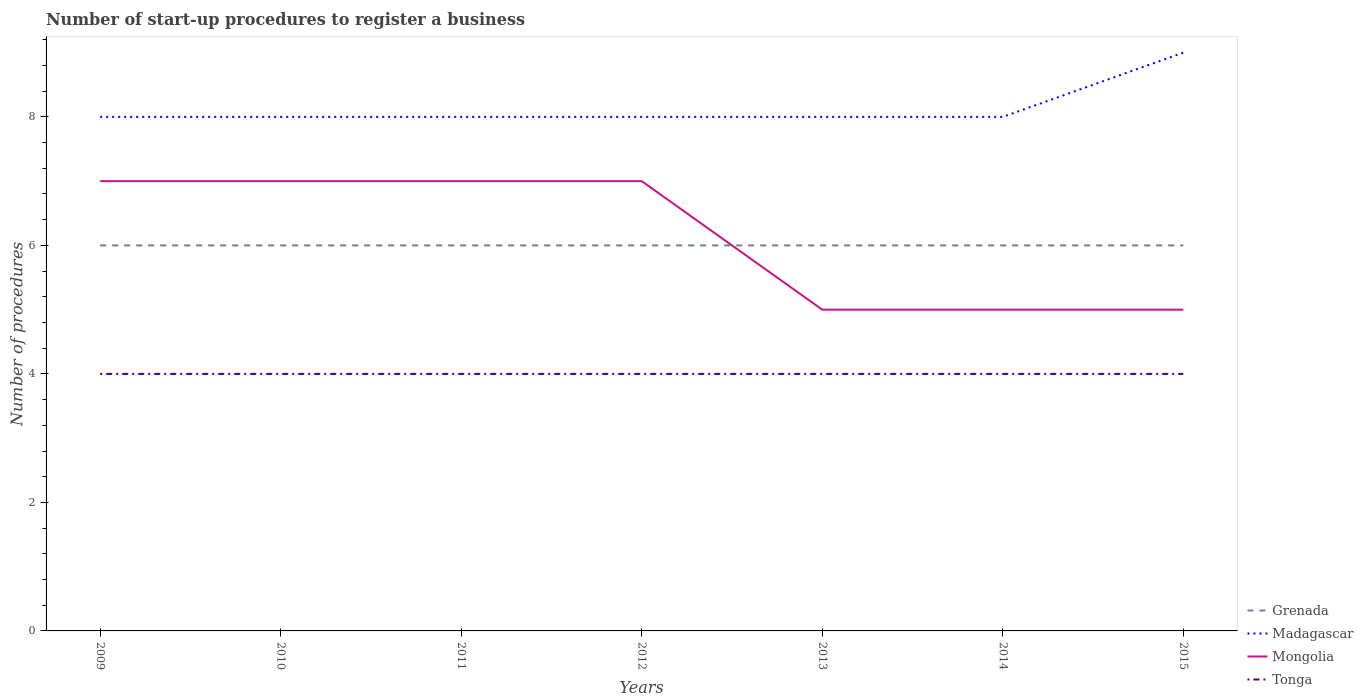Does the line corresponding to Tonga intersect with the line corresponding to Grenada?
Make the answer very short. No. Is the number of lines equal to the number of legend labels?
Offer a terse response. Yes. Across all years, what is the maximum number of procedures required to register a business in Madagascar?
Offer a terse response. 8. In which year was the number of procedures required to register a business in Tonga maximum?
Give a very brief answer. 2009. What is the difference between the highest and the second highest number of procedures required to register a business in Grenada?
Ensure brevity in your answer.  0. What is the difference between the highest and the lowest number of procedures required to register a business in Mongolia?
Your answer should be compact. 4. How many lines are there?
Ensure brevity in your answer.  4. Does the graph contain grids?
Provide a short and direct response. No. Where does the legend appear in the graph?
Offer a very short reply. Bottom right. How many legend labels are there?
Your answer should be compact. 4. How are the legend labels stacked?
Your answer should be compact. Vertical. What is the title of the graph?
Your answer should be compact. Number of start-up procedures to register a business. What is the label or title of the X-axis?
Offer a terse response. Years. What is the label or title of the Y-axis?
Your answer should be compact. Number of procedures. What is the Number of procedures of Grenada in 2009?
Provide a succinct answer. 6. What is the Number of procedures of Mongolia in 2009?
Your answer should be very brief. 7. What is the Number of procedures in Tonga in 2009?
Offer a very short reply. 4. What is the Number of procedures in Grenada in 2010?
Make the answer very short. 6. What is the Number of procedures of Madagascar in 2010?
Offer a terse response. 8. What is the Number of procedures of Mongolia in 2010?
Make the answer very short. 7. What is the Number of procedures in Tonga in 2010?
Your response must be concise. 4. What is the Number of procedures of Grenada in 2011?
Make the answer very short. 6. What is the Number of procedures of Mongolia in 2011?
Offer a very short reply. 7. What is the Number of procedures of Madagascar in 2012?
Make the answer very short. 8. What is the Number of procedures in Tonga in 2012?
Make the answer very short. 4. What is the Number of procedures of Madagascar in 2013?
Your answer should be very brief. 8. What is the Number of procedures of Mongolia in 2013?
Offer a very short reply. 5. What is the Number of procedures of Tonga in 2013?
Give a very brief answer. 4. What is the Number of procedures in Madagascar in 2014?
Provide a succinct answer. 8. What is the Number of procedures of Tonga in 2014?
Make the answer very short. 4. What is the Number of procedures in Madagascar in 2015?
Keep it short and to the point. 9. What is the Number of procedures in Mongolia in 2015?
Provide a succinct answer. 5. Across all years, what is the maximum Number of procedures in Grenada?
Give a very brief answer. 6. Across all years, what is the maximum Number of procedures of Tonga?
Keep it short and to the point. 4. Across all years, what is the minimum Number of procedures in Grenada?
Provide a succinct answer. 6. Across all years, what is the minimum Number of procedures of Mongolia?
Make the answer very short. 5. Across all years, what is the minimum Number of procedures of Tonga?
Provide a short and direct response. 4. What is the total Number of procedures of Grenada in the graph?
Your answer should be compact. 42. What is the total Number of procedures of Tonga in the graph?
Offer a very short reply. 28. What is the difference between the Number of procedures of Mongolia in 2009 and that in 2010?
Make the answer very short. 0. What is the difference between the Number of procedures in Tonga in 2009 and that in 2010?
Your answer should be compact. 0. What is the difference between the Number of procedures of Madagascar in 2009 and that in 2011?
Offer a terse response. 0. What is the difference between the Number of procedures in Mongolia in 2009 and that in 2011?
Offer a terse response. 0. What is the difference between the Number of procedures in Tonga in 2009 and that in 2011?
Your answer should be very brief. 0. What is the difference between the Number of procedures in Madagascar in 2009 and that in 2012?
Offer a very short reply. 0. What is the difference between the Number of procedures in Tonga in 2009 and that in 2012?
Provide a succinct answer. 0. What is the difference between the Number of procedures of Grenada in 2009 and that in 2013?
Keep it short and to the point. 0. What is the difference between the Number of procedures of Madagascar in 2009 and that in 2013?
Offer a terse response. 0. What is the difference between the Number of procedures of Grenada in 2009 and that in 2014?
Provide a succinct answer. 0. What is the difference between the Number of procedures in Madagascar in 2009 and that in 2014?
Your answer should be compact. 0. What is the difference between the Number of procedures of Madagascar in 2009 and that in 2015?
Give a very brief answer. -1. What is the difference between the Number of procedures in Mongolia in 2009 and that in 2015?
Your answer should be very brief. 2. What is the difference between the Number of procedures in Tonga in 2010 and that in 2011?
Offer a terse response. 0. What is the difference between the Number of procedures in Grenada in 2010 and that in 2012?
Keep it short and to the point. 0. What is the difference between the Number of procedures in Madagascar in 2010 and that in 2013?
Offer a terse response. 0. What is the difference between the Number of procedures in Mongolia in 2010 and that in 2013?
Provide a succinct answer. 2. What is the difference between the Number of procedures in Tonga in 2010 and that in 2013?
Keep it short and to the point. 0. What is the difference between the Number of procedures of Grenada in 2010 and that in 2014?
Provide a short and direct response. 0. What is the difference between the Number of procedures of Madagascar in 2010 and that in 2014?
Offer a terse response. 0. What is the difference between the Number of procedures in Mongolia in 2010 and that in 2014?
Give a very brief answer. 2. What is the difference between the Number of procedures of Tonga in 2010 and that in 2014?
Offer a terse response. 0. What is the difference between the Number of procedures in Grenada in 2010 and that in 2015?
Make the answer very short. 0. What is the difference between the Number of procedures in Mongolia in 2010 and that in 2015?
Make the answer very short. 2. What is the difference between the Number of procedures of Tonga in 2010 and that in 2015?
Provide a short and direct response. 0. What is the difference between the Number of procedures in Grenada in 2011 and that in 2012?
Keep it short and to the point. 0. What is the difference between the Number of procedures of Mongolia in 2011 and that in 2012?
Keep it short and to the point. 0. What is the difference between the Number of procedures in Tonga in 2011 and that in 2012?
Provide a succinct answer. 0. What is the difference between the Number of procedures of Grenada in 2011 and that in 2013?
Make the answer very short. 0. What is the difference between the Number of procedures of Madagascar in 2011 and that in 2013?
Offer a terse response. 0. What is the difference between the Number of procedures of Tonga in 2011 and that in 2013?
Keep it short and to the point. 0. What is the difference between the Number of procedures in Mongolia in 2011 and that in 2014?
Make the answer very short. 2. What is the difference between the Number of procedures in Madagascar in 2011 and that in 2015?
Your answer should be compact. -1. What is the difference between the Number of procedures of Mongolia in 2011 and that in 2015?
Make the answer very short. 2. What is the difference between the Number of procedures in Grenada in 2012 and that in 2013?
Your answer should be compact. 0. What is the difference between the Number of procedures in Mongolia in 2012 and that in 2013?
Offer a very short reply. 2. What is the difference between the Number of procedures in Madagascar in 2012 and that in 2014?
Offer a terse response. 0. What is the difference between the Number of procedures of Madagascar in 2012 and that in 2015?
Ensure brevity in your answer.  -1. What is the difference between the Number of procedures in Mongolia in 2012 and that in 2015?
Offer a very short reply. 2. What is the difference between the Number of procedures in Madagascar in 2013 and that in 2014?
Give a very brief answer. 0. What is the difference between the Number of procedures of Mongolia in 2013 and that in 2014?
Provide a short and direct response. 0. What is the difference between the Number of procedures of Grenada in 2013 and that in 2015?
Your answer should be compact. 0. What is the difference between the Number of procedures in Madagascar in 2014 and that in 2015?
Provide a succinct answer. -1. What is the difference between the Number of procedures of Grenada in 2009 and the Number of procedures of Madagascar in 2010?
Offer a very short reply. -2. What is the difference between the Number of procedures in Grenada in 2009 and the Number of procedures in Mongolia in 2010?
Your answer should be compact. -1. What is the difference between the Number of procedures of Grenada in 2009 and the Number of procedures of Tonga in 2010?
Ensure brevity in your answer.  2. What is the difference between the Number of procedures in Mongolia in 2009 and the Number of procedures in Tonga in 2010?
Your answer should be compact. 3. What is the difference between the Number of procedures of Grenada in 2009 and the Number of procedures of Madagascar in 2011?
Provide a short and direct response. -2. What is the difference between the Number of procedures of Grenada in 2009 and the Number of procedures of Mongolia in 2011?
Make the answer very short. -1. What is the difference between the Number of procedures in Grenada in 2009 and the Number of procedures in Tonga in 2011?
Provide a short and direct response. 2. What is the difference between the Number of procedures of Mongolia in 2009 and the Number of procedures of Tonga in 2011?
Your answer should be very brief. 3. What is the difference between the Number of procedures of Grenada in 2009 and the Number of procedures of Madagascar in 2012?
Provide a short and direct response. -2. What is the difference between the Number of procedures in Madagascar in 2009 and the Number of procedures in Mongolia in 2012?
Provide a short and direct response. 1. What is the difference between the Number of procedures in Madagascar in 2009 and the Number of procedures in Tonga in 2012?
Keep it short and to the point. 4. What is the difference between the Number of procedures of Mongolia in 2009 and the Number of procedures of Tonga in 2012?
Give a very brief answer. 3. What is the difference between the Number of procedures of Mongolia in 2009 and the Number of procedures of Tonga in 2013?
Your answer should be very brief. 3. What is the difference between the Number of procedures in Grenada in 2009 and the Number of procedures in Madagascar in 2014?
Your answer should be compact. -2. What is the difference between the Number of procedures in Grenada in 2009 and the Number of procedures in Mongolia in 2014?
Make the answer very short. 1. What is the difference between the Number of procedures of Grenada in 2009 and the Number of procedures of Tonga in 2014?
Provide a short and direct response. 2. What is the difference between the Number of procedures in Madagascar in 2009 and the Number of procedures in Mongolia in 2014?
Offer a very short reply. 3. What is the difference between the Number of procedures in Mongolia in 2009 and the Number of procedures in Tonga in 2014?
Provide a succinct answer. 3. What is the difference between the Number of procedures in Grenada in 2009 and the Number of procedures in Mongolia in 2015?
Keep it short and to the point. 1. What is the difference between the Number of procedures of Grenada in 2009 and the Number of procedures of Tonga in 2015?
Offer a very short reply. 2. What is the difference between the Number of procedures of Grenada in 2010 and the Number of procedures of Madagascar in 2011?
Make the answer very short. -2. What is the difference between the Number of procedures of Madagascar in 2010 and the Number of procedures of Tonga in 2011?
Your answer should be compact. 4. What is the difference between the Number of procedures of Grenada in 2010 and the Number of procedures of Mongolia in 2012?
Provide a short and direct response. -1. What is the difference between the Number of procedures of Grenada in 2010 and the Number of procedures of Tonga in 2012?
Ensure brevity in your answer.  2. What is the difference between the Number of procedures of Madagascar in 2010 and the Number of procedures of Tonga in 2012?
Your answer should be compact. 4. What is the difference between the Number of procedures in Grenada in 2010 and the Number of procedures in Tonga in 2013?
Offer a very short reply. 2. What is the difference between the Number of procedures in Mongolia in 2010 and the Number of procedures in Tonga in 2013?
Give a very brief answer. 3. What is the difference between the Number of procedures in Grenada in 2010 and the Number of procedures in Madagascar in 2014?
Give a very brief answer. -2. What is the difference between the Number of procedures of Madagascar in 2010 and the Number of procedures of Mongolia in 2014?
Provide a succinct answer. 3. What is the difference between the Number of procedures of Madagascar in 2010 and the Number of procedures of Tonga in 2014?
Offer a very short reply. 4. What is the difference between the Number of procedures of Mongolia in 2010 and the Number of procedures of Tonga in 2014?
Your answer should be compact. 3. What is the difference between the Number of procedures in Grenada in 2010 and the Number of procedures in Madagascar in 2015?
Offer a very short reply. -3. What is the difference between the Number of procedures in Grenada in 2010 and the Number of procedures in Mongolia in 2015?
Provide a succinct answer. 1. What is the difference between the Number of procedures in Madagascar in 2010 and the Number of procedures in Tonga in 2015?
Offer a terse response. 4. What is the difference between the Number of procedures in Mongolia in 2010 and the Number of procedures in Tonga in 2015?
Your answer should be compact. 3. What is the difference between the Number of procedures in Grenada in 2011 and the Number of procedures in Madagascar in 2012?
Offer a terse response. -2. What is the difference between the Number of procedures in Grenada in 2011 and the Number of procedures in Mongolia in 2012?
Give a very brief answer. -1. What is the difference between the Number of procedures of Madagascar in 2011 and the Number of procedures of Tonga in 2012?
Your answer should be compact. 4. What is the difference between the Number of procedures of Mongolia in 2011 and the Number of procedures of Tonga in 2012?
Offer a very short reply. 3. What is the difference between the Number of procedures of Grenada in 2011 and the Number of procedures of Mongolia in 2013?
Your response must be concise. 1. What is the difference between the Number of procedures in Grenada in 2011 and the Number of procedures in Tonga in 2013?
Offer a terse response. 2. What is the difference between the Number of procedures of Mongolia in 2011 and the Number of procedures of Tonga in 2013?
Provide a succinct answer. 3. What is the difference between the Number of procedures in Grenada in 2011 and the Number of procedures in Madagascar in 2014?
Give a very brief answer. -2. What is the difference between the Number of procedures of Grenada in 2011 and the Number of procedures of Mongolia in 2014?
Provide a short and direct response. 1. What is the difference between the Number of procedures of Mongolia in 2011 and the Number of procedures of Tonga in 2014?
Ensure brevity in your answer.  3. What is the difference between the Number of procedures of Grenada in 2011 and the Number of procedures of Madagascar in 2015?
Offer a very short reply. -3. What is the difference between the Number of procedures of Madagascar in 2011 and the Number of procedures of Tonga in 2015?
Provide a succinct answer. 4. What is the difference between the Number of procedures in Grenada in 2012 and the Number of procedures in Mongolia in 2013?
Your answer should be very brief. 1. What is the difference between the Number of procedures of Grenada in 2012 and the Number of procedures of Tonga in 2013?
Keep it short and to the point. 2. What is the difference between the Number of procedures in Madagascar in 2012 and the Number of procedures in Tonga in 2013?
Provide a short and direct response. 4. What is the difference between the Number of procedures of Grenada in 2012 and the Number of procedures of Madagascar in 2014?
Provide a short and direct response. -2. What is the difference between the Number of procedures in Grenada in 2012 and the Number of procedures in Mongolia in 2014?
Give a very brief answer. 1. What is the difference between the Number of procedures of Madagascar in 2012 and the Number of procedures of Mongolia in 2014?
Keep it short and to the point. 3. What is the difference between the Number of procedures of Madagascar in 2012 and the Number of procedures of Tonga in 2014?
Your response must be concise. 4. What is the difference between the Number of procedures in Grenada in 2012 and the Number of procedures in Madagascar in 2015?
Offer a terse response. -3. What is the difference between the Number of procedures of Grenada in 2012 and the Number of procedures of Mongolia in 2015?
Ensure brevity in your answer.  1. What is the difference between the Number of procedures of Grenada in 2012 and the Number of procedures of Tonga in 2015?
Keep it short and to the point. 2. What is the difference between the Number of procedures of Madagascar in 2012 and the Number of procedures of Mongolia in 2015?
Offer a terse response. 3. What is the difference between the Number of procedures in Madagascar in 2012 and the Number of procedures in Tonga in 2015?
Provide a succinct answer. 4. What is the difference between the Number of procedures of Mongolia in 2012 and the Number of procedures of Tonga in 2015?
Offer a terse response. 3. What is the difference between the Number of procedures in Madagascar in 2013 and the Number of procedures in Tonga in 2014?
Offer a very short reply. 4. What is the difference between the Number of procedures of Mongolia in 2013 and the Number of procedures of Tonga in 2014?
Provide a succinct answer. 1. What is the difference between the Number of procedures of Grenada in 2013 and the Number of procedures of Madagascar in 2015?
Your answer should be compact. -3. What is the difference between the Number of procedures in Grenada in 2013 and the Number of procedures in Mongolia in 2015?
Provide a short and direct response. 1. What is the difference between the Number of procedures in Grenada in 2013 and the Number of procedures in Tonga in 2015?
Give a very brief answer. 2. What is the difference between the Number of procedures in Madagascar in 2013 and the Number of procedures in Mongolia in 2015?
Provide a succinct answer. 3. What is the difference between the Number of procedures of Grenada in 2014 and the Number of procedures of Madagascar in 2015?
Provide a short and direct response. -3. What is the difference between the Number of procedures of Grenada in 2014 and the Number of procedures of Mongolia in 2015?
Make the answer very short. 1. What is the average Number of procedures in Madagascar per year?
Make the answer very short. 8.14. What is the average Number of procedures of Mongolia per year?
Give a very brief answer. 6.14. What is the average Number of procedures in Tonga per year?
Your response must be concise. 4. In the year 2009, what is the difference between the Number of procedures in Grenada and Number of procedures in Mongolia?
Your answer should be compact. -1. In the year 2009, what is the difference between the Number of procedures of Grenada and Number of procedures of Tonga?
Make the answer very short. 2. In the year 2009, what is the difference between the Number of procedures in Madagascar and Number of procedures in Tonga?
Provide a succinct answer. 4. In the year 2010, what is the difference between the Number of procedures in Grenada and Number of procedures in Madagascar?
Your answer should be very brief. -2. In the year 2010, what is the difference between the Number of procedures of Grenada and Number of procedures of Tonga?
Provide a succinct answer. 2. In the year 2010, what is the difference between the Number of procedures in Madagascar and Number of procedures in Tonga?
Offer a terse response. 4. In the year 2011, what is the difference between the Number of procedures of Grenada and Number of procedures of Mongolia?
Give a very brief answer. -1. In the year 2011, what is the difference between the Number of procedures of Grenada and Number of procedures of Tonga?
Offer a very short reply. 2. In the year 2011, what is the difference between the Number of procedures in Madagascar and Number of procedures in Mongolia?
Provide a short and direct response. 1. In the year 2012, what is the difference between the Number of procedures in Grenada and Number of procedures in Madagascar?
Ensure brevity in your answer.  -2. In the year 2012, what is the difference between the Number of procedures of Grenada and Number of procedures of Mongolia?
Your response must be concise. -1. In the year 2013, what is the difference between the Number of procedures in Grenada and Number of procedures in Mongolia?
Your answer should be compact. 1. In the year 2013, what is the difference between the Number of procedures in Madagascar and Number of procedures in Tonga?
Keep it short and to the point. 4. In the year 2014, what is the difference between the Number of procedures of Grenada and Number of procedures of Madagascar?
Offer a terse response. -2. In the year 2014, what is the difference between the Number of procedures of Grenada and Number of procedures of Mongolia?
Make the answer very short. 1. In the year 2014, what is the difference between the Number of procedures in Mongolia and Number of procedures in Tonga?
Give a very brief answer. 1. In the year 2015, what is the difference between the Number of procedures in Grenada and Number of procedures in Tonga?
Keep it short and to the point. 2. What is the ratio of the Number of procedures of Madagascar in 2009 to that in 2010?
Your answer should be compact. 1. What is the ratio of the Number of procedures in Grenada in 2009 to that in 2011?
Make the answer very short. 1. What is the ratio of the Number of procedures of Madagascar in 2009 to that in 2011?
Provide a short and direct response. 1. What is the ratio of the Number of procedures in Tonga in 2009 to that in 2011?
Your response must be concise. 1. What is the ratio of the Number of procedures of Tonga in 2009 to that in 2012?
Your answer should be very brief. 1. What is the ratio of the Number of procedures of Grenada in 2009 to that in 2014?
Offer a terse response. 1. What is the ratio of the Number of procedures of Tonga in 2009 to that in 2014?
Make the answer very short. 1. What is the ratio of the Number of procedures of Madagascar in 2010 to that in 2011?
Your answer should be compact. 1. What is the ratio of the Number of procedures in Tonga in 2010 to that in 2011?
Your response must be concise. 1. What is the ratio of the Number of procedures of Madagascar in 2010 to that in 2012?
Provide a succinct answer. 1. What is the ratio of the Number of procedures in Tonga in 2010 to that in 2012?
Ensure brevity in your answer.  1. What is the ratio of the Number of procedures in Grenada in 2010 to that in 2013?
Give a very brief answer. 1. What is the ratio of the Number of procedures in Grenada in 2010 to that in 2014?
Your answer should be very brief. 1. What is the ratio of the Number of procedures of Madagascar in 2010 to that in 2014?
Offer a very short reply. 1. What is the ratio of the Number of procedures of Tonga in 2010 to that in 2014?
Your answer should be very brief. 1. What is the ratio of the Number of procedures in Madagascar in 2010 to that in 2015?
Give a very brief answer. 0.89. What is the ratio of the Number of procedures in Tonga in 2011 to that in 2012?
Provide a short and direct response. 1. What is the ratio of the Number of procedures of Grenada in 2011 to that in 2013?
Keep it short and to the point. 1. What is the ratio of the Number of procedures in Madagascar in 2011 to that in 2013?
Give a very brief answer. 1. What is the ratio of the Number of procedures in Madagascar in 2011 to that in 2014?
Your answer should be compact. 1. What is the ratio of the Number of procedures of Tonga in 2011 to that in 2014?
Provide a short and direct response. 1. What is the ratio of the Number of procedures in Grenada in 2011 to that in 2015?
Provide a succinct answer. 1. What is the ratio of the Number of procedures of Madagascar in 2011 to that in 2015?
Your answer should be very brief. 0.89. What is the ratio of the Number of procedures in Madagascar in 2012 to that in 2013?
Provide a short and direct response. 1. What is the ratio of the Number of procedures of Mongolia in 2012 to that in 2013?
Keep it short and to the point. 1.4. What is the ratio of the Number of procedures of Mongolia in 2012 to that in 2014?
Provide a short and direct response. 1.4. What is the ratio of the Number of procedures of Tonga in 2012 to that in 2014?
Provide a short and direct response. 1. What is the ratio of the Number of procedures of Grenada in 2013 to that in 2014?
Make the answer very short. 1. What is the ratio of the Number of procedures of Madagascar in 2013 to that in 2014?
Offer a very short reply. 1. What is the ratio of the Number of procedures in Tonga in 2013 to that in 2014?
Keep it short and to the point. 1. What is the ratio of the Number of procedures in Grenada in 2013 to that in 2015?
Your response must be concise. 1. What is the ratio of the Number of procedures of Madagascar in 2013 to that in 2015?
Keep it short and to the point. 0.89. What is the ratio of the Number of procedures in Tonga in 2013 to that in 2015?
Make the answer very short. 1. What is the ratio of the Number of procedures of Grenada in 2014 to that in 2015?
Ensure brevity in your answer.  1. What is the ratio of the Number of procedures of Mongolia in 2014 to that in 2015?
Offer a terse response. 1. What is the ratio of the Number of procedures of Tonga in 2014 to that in 2015?
Offer a very short reply. 1. What is the difference between the highest and the second highest Number of procedures in Madagascar?
Ensure brevity in your answer.  1. What is the difference between the highest and the second highest Number of procedures in Mongolia?
Your response must be concise. 0. What is the difference between the highest and the second highest Number of procedures of Tonga?
Make the answer very short. 0. 